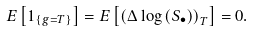<formula> <loc_0><loc_0><loc_500><loc_500>E \left [ 1 _ { \left \{ g = T \right \} } \right ] = E \left [ \left ( \Delta \log \left ( S _ { \bullet } \right ) \right ) _ { T } \right ] = 0 .</formula> 